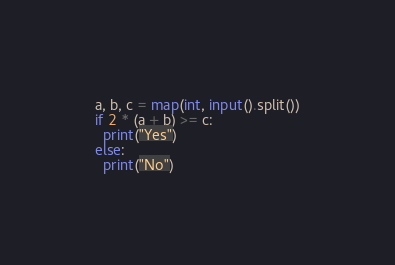<code> <loc_0><loc_0><loc_500><loc_500><_Python_>a, b, c = map(int, input().split())
if 2 * (a + b) >= c:
  print("Yes")
else:
  print("No")</code> 